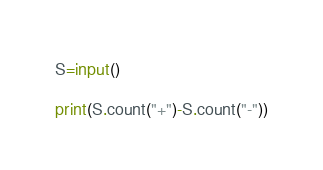<code> <loc_0><loc_0><loc_500><loc_500><_Python_>S=input()

print(S.count("+")-S.count("-"))</code> 